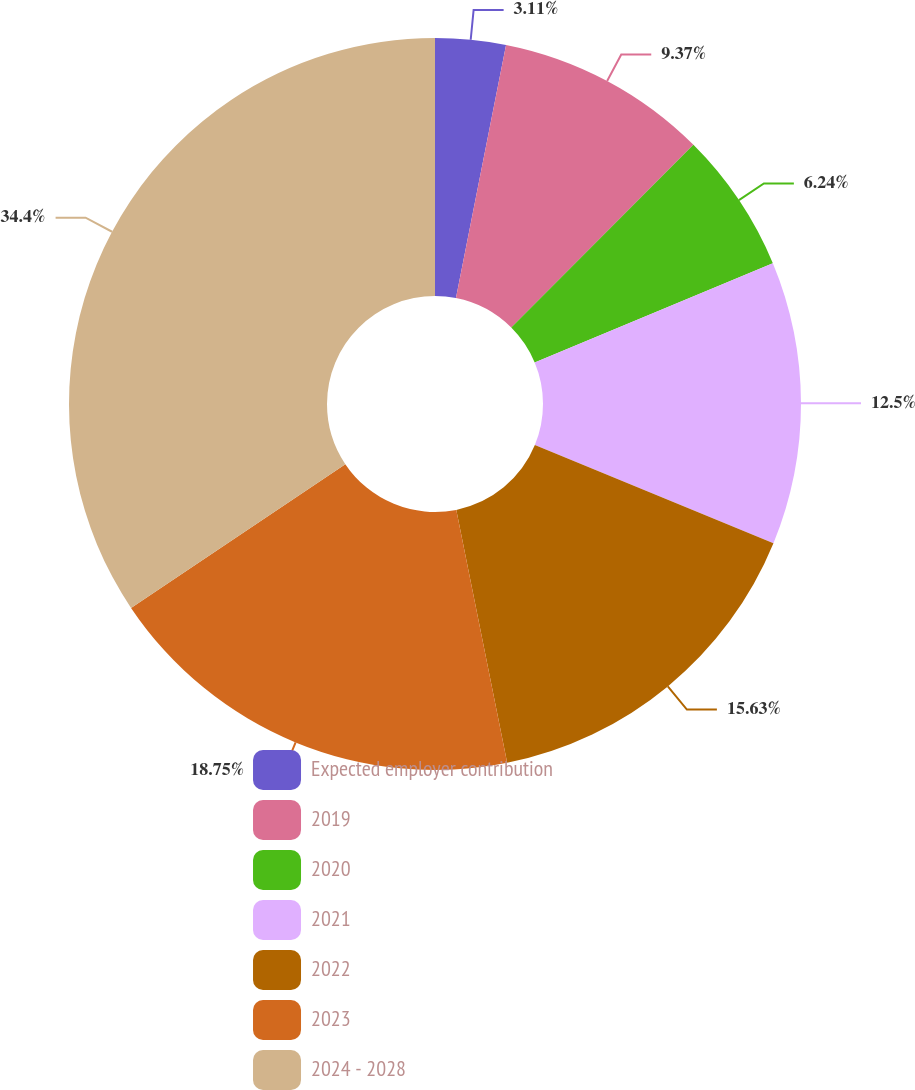Convert chart to OTSL. <chart><loc_0><loc_0><loc_500><loc_500><pie_chart><fcel>Expected employer contribution<fcel>2019<fcel>2020<fcel>2021<fcel>2022<fcel>2023<fcel>2024 - 2028<nl><fcel>3.11%<fcel>9.37%<fcel>6.24%<fcel>12.5%<fcel>15.63%<fcel>18.76%<fcel>34.41%<nl></chart> 